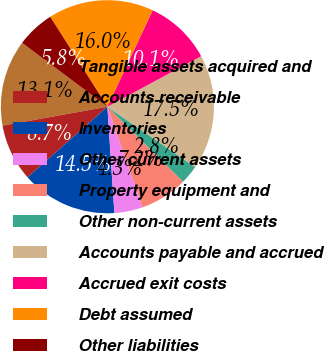Convert chart. <chart><loc_0><loc_0><loc_500><loc_500><pie_chart><fcel>Tangible assets acquired and<fcel>Accounts receivable<fcel>Inventories<fcel>Other current assets<fcel>Property equipment and<fcel>Other non-current assets<fcel>Accounts payable and accrued<fcel>Accrued exit costs<fcel>Debt assumed<fcel>Other liabilities<nl><fcel>13.07%<fcel>8.68%<fcel>14.53%<fcel>4.3%<fcel>7.22%<fcel>2.83%<fcel>17.46%<fcel>10.15%<fcel>16.0%<fcel>5.76%<nl></chart> 